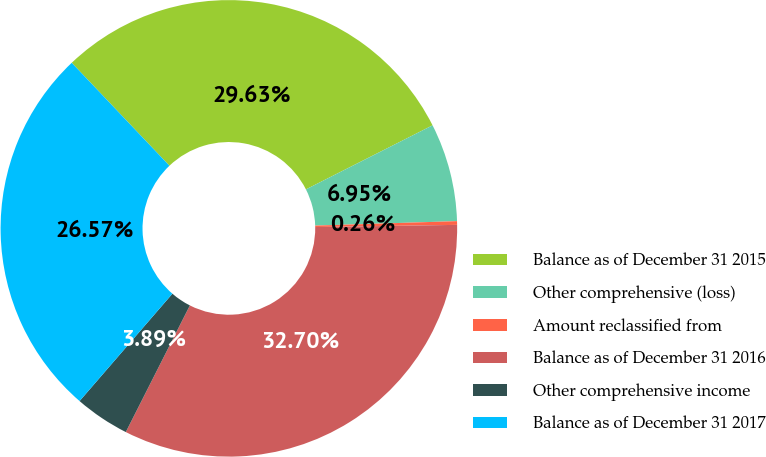Convert chart to OTSL. <chart><loc_0><loc_0><loc_500><loc_500><pie_chart><fcel>Balance as of December 31 2015<fcel>Other comprehensive (loss)<fcel>Amount reclassified from<fcel>Balance as of December 31 2016<fcel>Other comprehensive income<fcel>Balance as of December 31 2017<nl><fcel>29.63%<fcel>6.95%<fcel>0.26%<fcel>32.7%<fcel>3.89%<fcel>26.57%<nl></chart> 